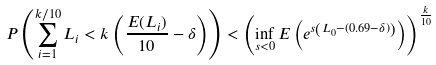<formula> <loc_0><loc_0><loc_500><loc_500>P \left ( \sum _ { i = 1 } ^ { k / 1 0 } L _ { i } < k \left ( \frac { E ( L _ { i } ) } { 1 0 } - \delta \right ) \right ) < \left ( \inf _ { s < 0 } E \left ( e ^ { s \left ( L _ { 0 } - ( 0 . 6 9 - \delta ) \right ) } \right ) \right ) ^ { \frac { k } { 1 0 } }</formula> 